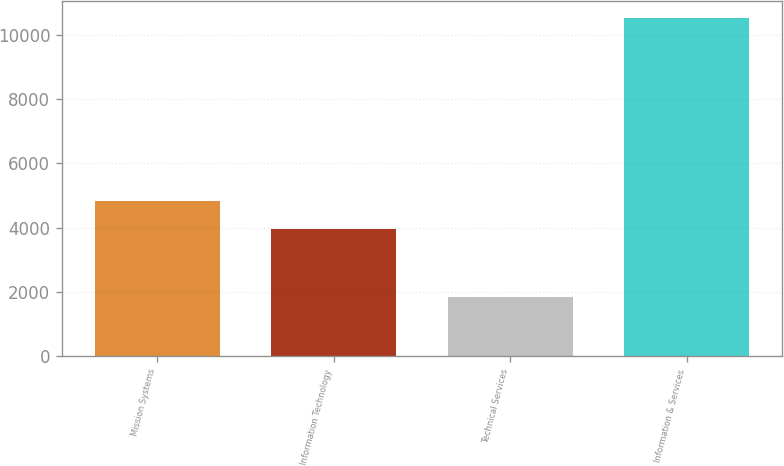Convert chart. <chart><loc_0><loc_0><loc_500><loc_500><bar_chart><fcel>Mission Systems<fcel>Information Technology<fcel>Technical Services<fcel>Information & Services<nl><fcel>4828.6<fcel>3962<fcel>1858<fcel>10524<nl></chart> 